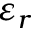<formula> <loc_0><loc_0><loc_500><loc_500>\varepsilon _ { r }</formula> 